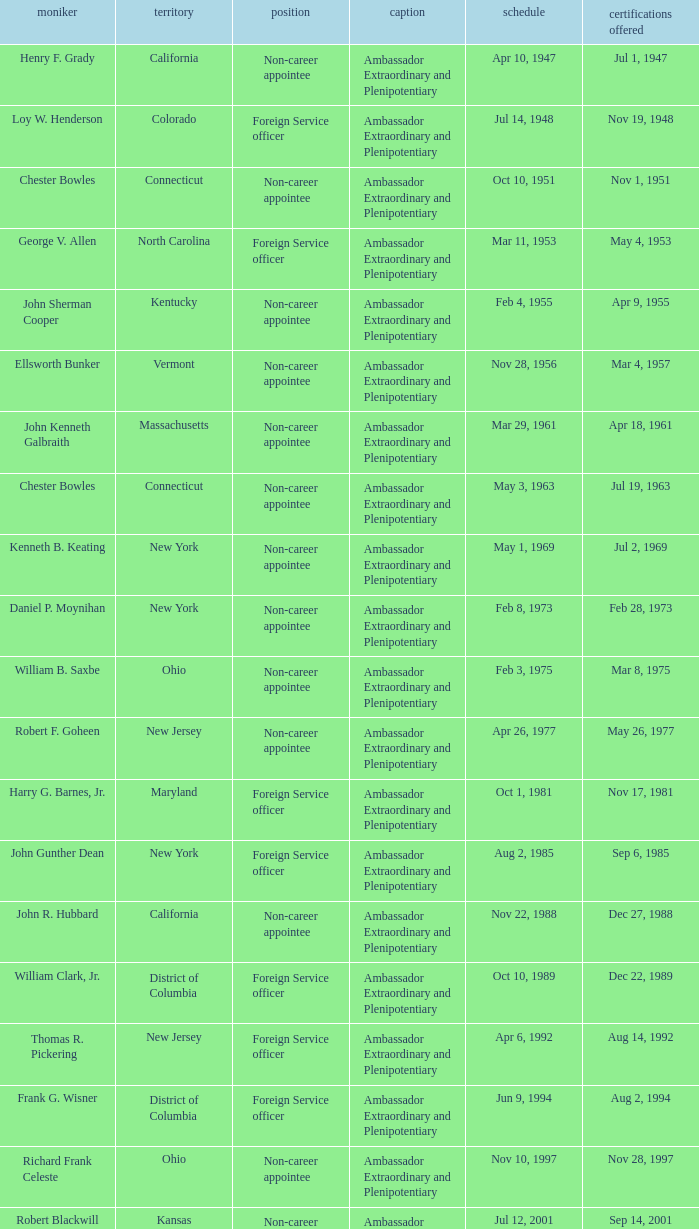What state has an appointment for jul 12, 2001? Kansas. 